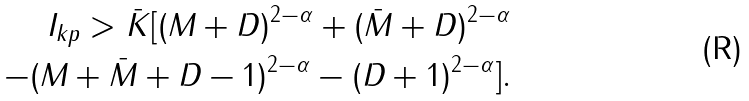Convert formula to latex. <formula><loc_0><loc_0><loc_500><loc_500>I _ { k p } > \bar { K } [ ( M + D ) ^ { 2 - \alpha } + ( \bar { M } + D ) ^ { 2 - \alpha } \\ - ( M + \bar { M } + D - 1 ) ^ { 2 - \alpha } - ( D + 1 ) ^ { 2 - \alpha } ] .</formula> 